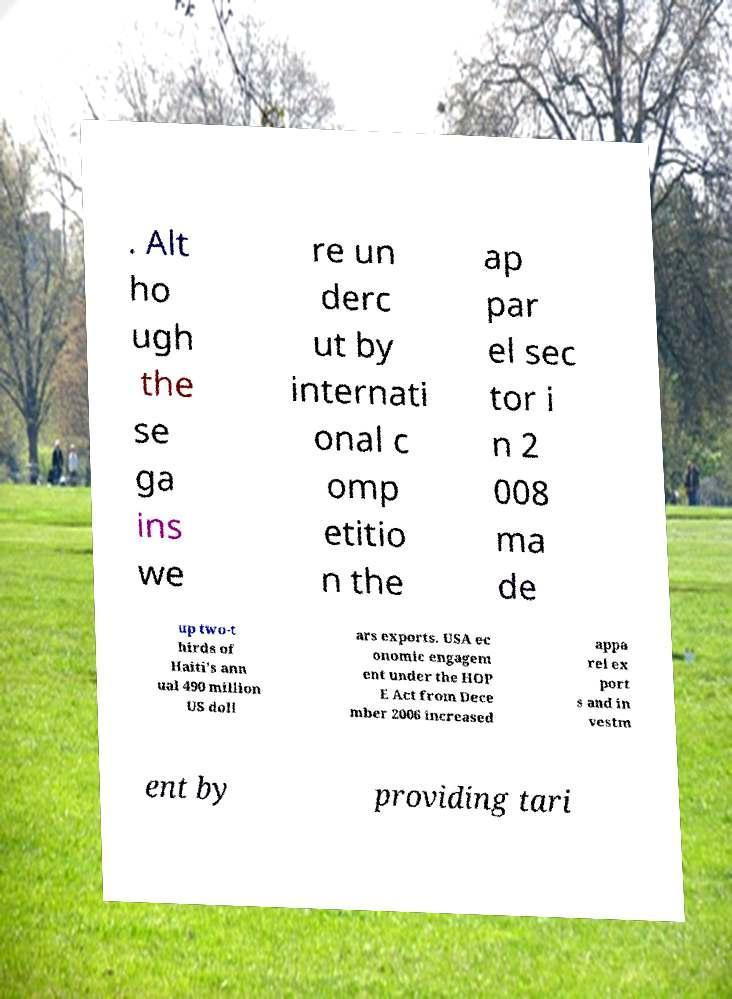What messages or text are displayed in this image? I need them in a readable, typed format. . Alt ho ugh the se ga ins we re un derc ut by internati onal c omp etitio n the ap par el sec tor i n 2 008 ma de up two-t hirds of Haiti's ann ual 490 million US doll ars exports. USA ec onomic engagem ent under the HOP E Act from Dece mber 2006 increased appa rel ex port s and in vestm ent by providing tari 